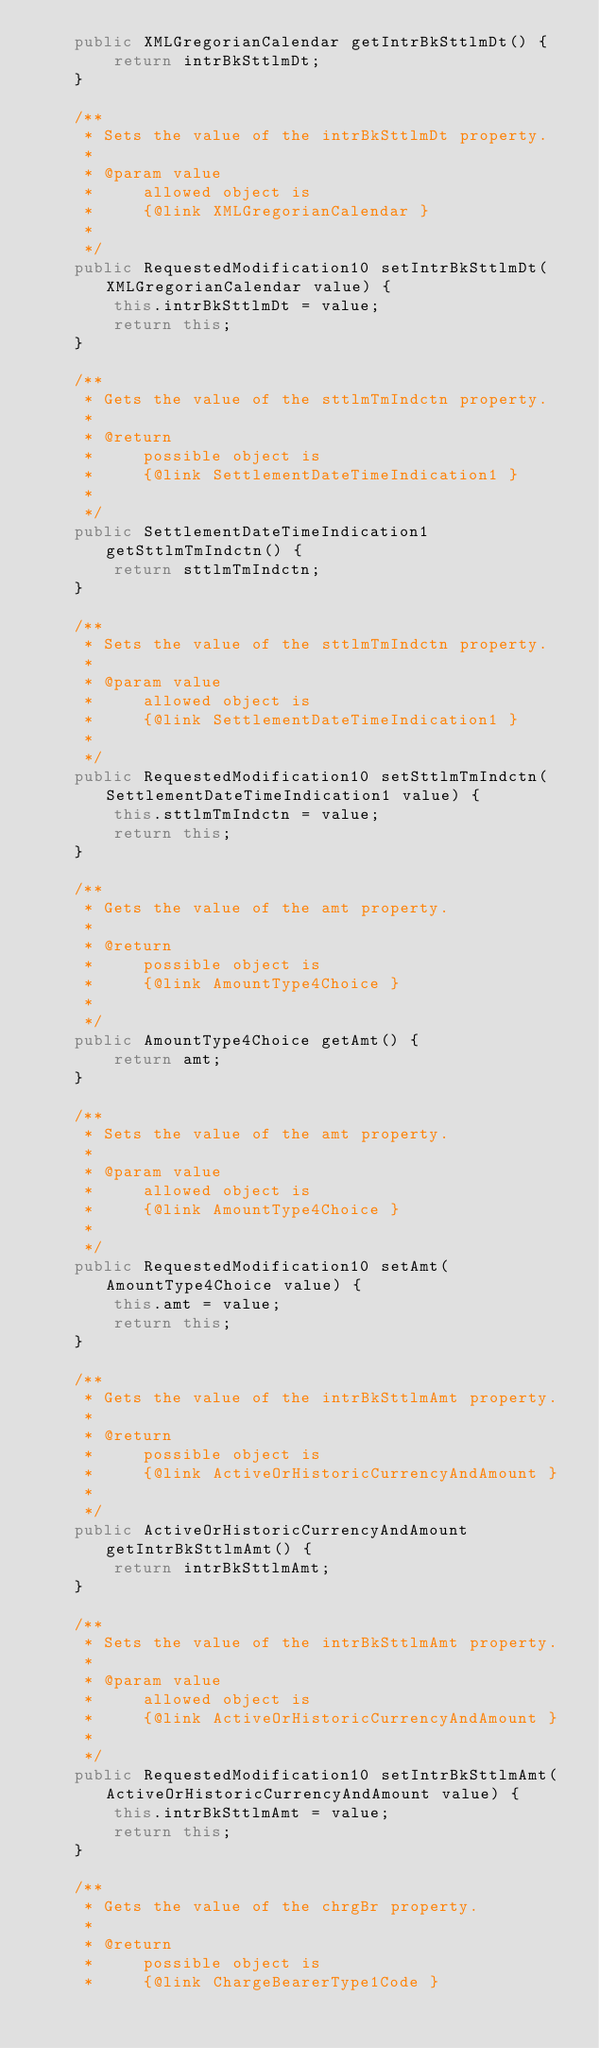Convert code to text. <code><loc_0><loc_0><loc_500><loc_500><_Java_>    public XMLGregorianCalendar getIntrBkSttlmDt() {
        return intrBkSttlmDt;
    }

    /**
     * Sets the value of the intrBkSttlmDt property.
     * 
     * @param value
     *     allowed object is
     *     {@link XMLGregorianCalendar }
     *     
     */
    public RequestedModification10 setIntrBkSttlmDt(XMLGregorianCalendar value) {
        this.intrBkSttlmDt = value;
        return this;
    }

    /**
     * Gets the value of the sttlmTmIndctn property.
     * 
     * @return
     *     possible object is
     *     {@link SettlementDateTimeIndication1 }
     *     
     */
    public SettlementDateTimeIndication1 getSttlmTmIndctn() {
        return sttlmTmIndctn;
    }

    /**
     * Sets the value of the sttlmTmIndctn property.
     * 
     * @param value
     *     allowed object is
     *     {@link SettlementDateTimeIndication1 }
     *     
     */
    public RequestedModification10 setSttlmTmIndctn(SettlementDateTimeIndication1 value) {
        this.sttlmTmIndctn = value;
        return this;
    }

    /**
     * Gets the value of the amt property.
     * 
     * @return
     *     possible object is
     *     {@link AmountType4Choice }
     *     
     */
    public AmountType4Choice getAmt() {
        return amt;
    }

    /**
     * Sets the value of the amt property.
     * 
     * @param value
     *     allowed object is
     *     {@link AmountType4Choice }
     *     
     */
    public RequestedModification10 setAmt(AmountType4Choice value) {
        this.amt = value;
        return this;
    }

    /**
     * Gets the value of the intrBkSttlmAmt property.
     * 
     * @return
     *     possible object is
     *     {@link ActiveOrHistoricCurrencyAndAmount }
     *     
     */
    public ActiveOrHistoricCurrencyAndAmount getIntrBkSttlmAmt() {
        return intrBkSttlmAmt;
    }

    /**
     * Sets the value of the intrBkSttlmAmt property.
     * 
     * @param value
     *     allowed object is
     *     {@link ActiveOrHistoricCurrencyAndAmount }
     *     
     */
    public RequestedModification10 setIntrBkSttlmAmt(ActiveOrHistoricCurrencyAndAmount value) {
        this.intrBkSttlmAmt = value;
        return this;
    }

    /**
     * Gets the value of the chrgBr property.
     * 
     * @return
     *     possible object is
     *     {@link ChargeBearerType1Code }</code> 